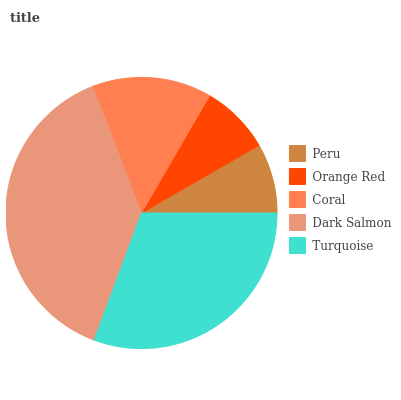Is Peru the minimum?
Answer yes or no. Yes. Is Dark Salmon the maximum?
Answer yes or no. Yes. Is Orange Red the minimum?
Answer yes or no. No. Is Orange Red the maximum?
Answer yes or no. No. Is Orange Red greater than Peru?
Answer yes or no. Yes. Is Peru less than Orange Red?
Answer yes or no. Yes. Is Peru greater than Orange Red?
Answer yes or no. No. Is Orange Red less than Peru?
Answer yes or no. No. Is Coral the high median?
Answer yes or no. Yes. Is Coral the low median?
Answer yes or no. Yes. Is Dark Salmon the high median?
Answer yes or no. No. Is Turquoise the low median?
Answer yes or no. No. 